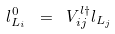Convert formula to latex. <formula><loc_0><loc_0><loc_500><loc_500>l ^ { 0 } _ { L _ { i } } \ = \ V ^ { l \dagger } _ { i j } l _ { L _ { j } }</formula> 